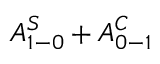<formula> <loc_0><loc_0><loc_500><loc_500>A _ { 1 - 0 } ^ { S } + A _ { 0 - 1 } ^ { C }</formula> 